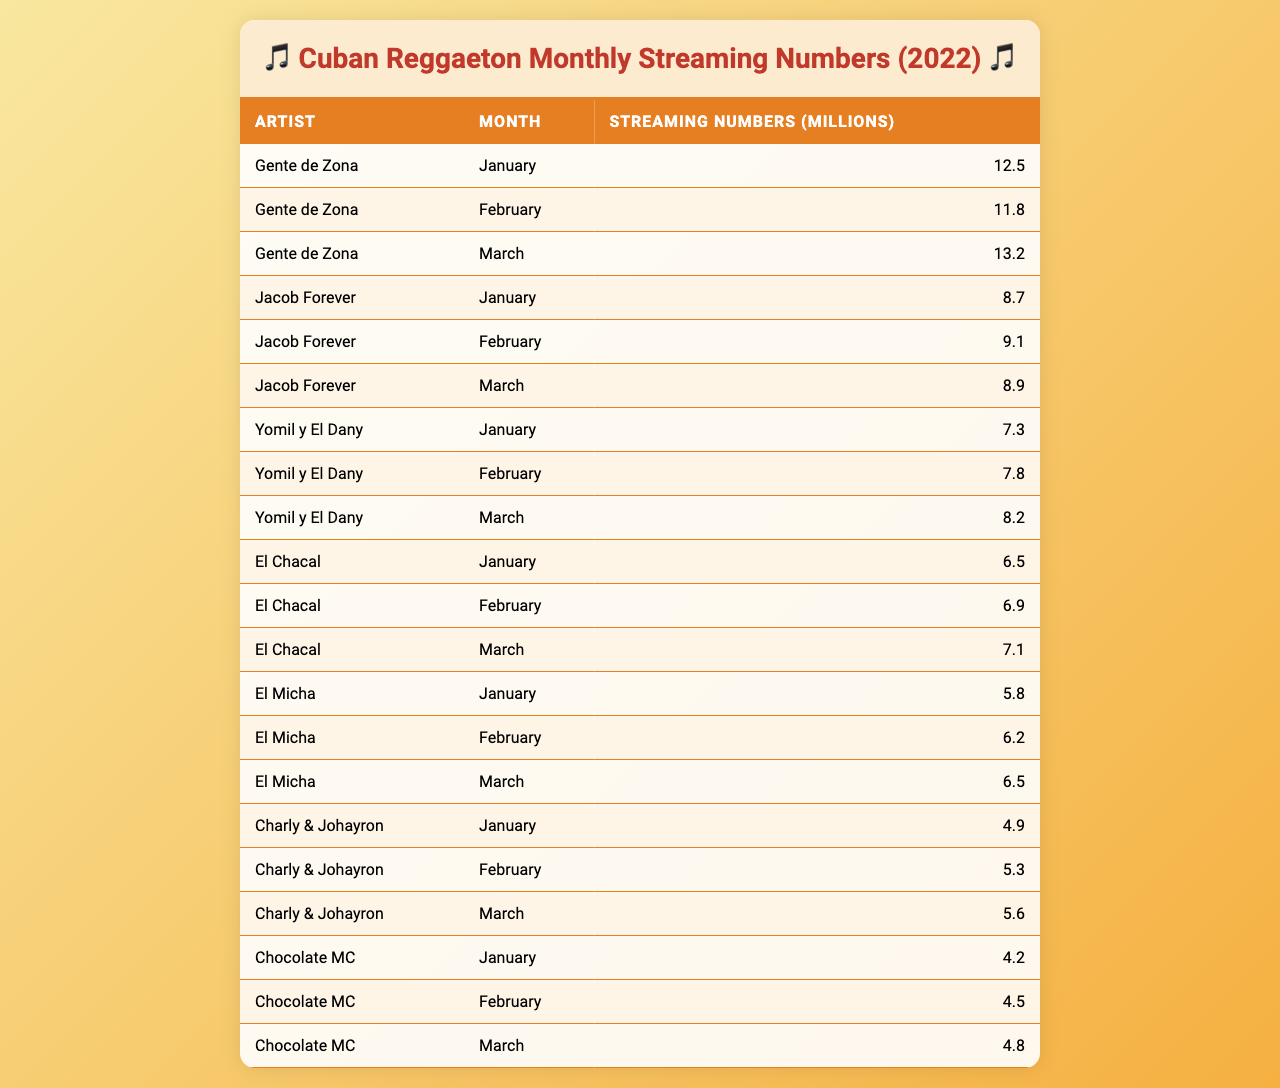What are the streaming numbers for Gente de Zona in March? In the table, the row for Gente de Zona under the month of March shows the streaming numbers as 13.2 million.
Answer: 13.2 million Which artist had the highest streaming numbers in January? By examining the table, we can see that Gente de Zona had the highest streaming numbers in January with 12.5 million, compared to the other artists.
Answer: Gente de Zona What is the total number of streaming numbers for Jacob Forever over the first three months? To find the total for Jacob Forever, we add January (8.7), February (9.1), and March (8.9). The sum is 8.7 + 9.1 + 8.9 = 26.7 million.
Answer: 26.7 million Did El Micha's streaming numbers increase from January to March? Examining the table, El Micha had 5.8 million in January, 6.2 million in February, and 6.5 million in March, indicating an increase.
Answer: Yes What are the average monthly streaming numbers of Yomil y El Dany for the first quarter? The average is calculated by adding the streaming numbers for Yomil y El Dany over the three months (7.3 + 7.8 + 8.2 = 23.3) and then dividing by 3, resulting in 23.3 / 3 = 7.77 million.
Answer: 7.77 million Which Cuban artist has the lowest streaming numbers in February? By checking the February row, Chocolate MC has the lowest streaming numbers of 4.5 million compared to all artists listed.
Answer: Chocolate MC How much more did Gente de Zona stream than El Chacal in March? For March, Gente de Zona had 13.2 million and El Chacal had 7.1 million. The difference is 13.2 - 7.1 = 6.1 million.
Answer: 6.1 million What is the streaming trend for Chocolate MC from January to March? Looking at the numbers, Chocolate MC's streaming counts were 4.2 million in January, 4.5 million in February, and 4.8 million in March, indicating a steady increase each month.
Answer: Steady increase Which artist consistently had the lowest streaming numbers across all three months? By analyzing the entire table, Charly & Johayron had the lowest streaming numbers every month, making them the artist with the lowest numbers.
Answer: Charly & Johayron What are the total streaming numbers for all artists in February? We calculate the totals for February by adding up: Gente de Zona (11.8), Jacob Forever (9.1), Yomil y El Dany (7.8), El Chacal (6.9), El Micha (6.2), Charly & Johayron (5.3), and Chocolate MC (4.5), which totals to 51.6 million.
Answer: 51.6 million 